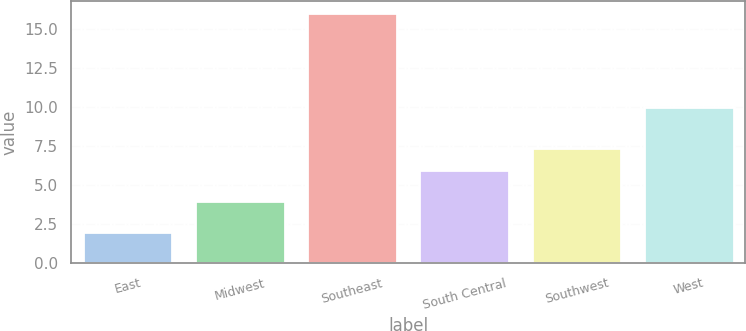<chart> <loc_0><loc_0><loc_500><loc_500><bar_chart><fcel>East<fcel>Midwest<fcel>Southeast<fcel>South Central<fcel>Southwest<fcel>West<nl><fcel>2<fcel>4<fcel>16<fcel>6<fcel>7.4<fcel>10<nl></chart> 